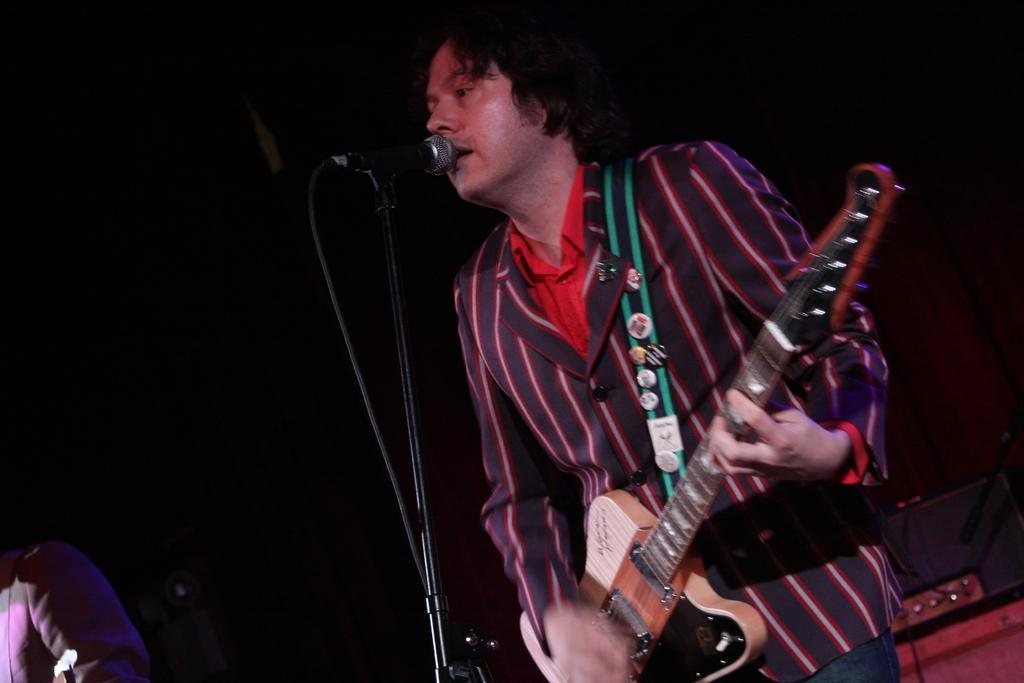What is the man in the image holding? The man is holding a guitar. What object is in front of the man? There is a microphone in front of the man. Can you see any leaves on the guitar in the image? There are no leaves present on the guitar in the image. Is there a drum visible in the image? There is no drum visible in the image. Are there any ladybugs crawling on the microphone in the image? There are no ladybugs present in the image. 